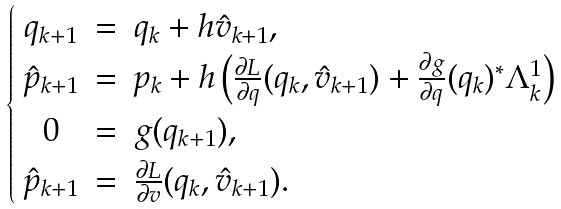Convert formula to latex. <formula><loc_0><loc_0><loc_500><loc_500>\begin{cases} \begin{array} { c c l } q _ { k + 1 } & = & q _ { k } + h \hat { v } _ { k + 1 } \text {,} \\ \hat { p } _ { k + 1 } & = & p _ { k } + h \left ( \frac { \partial L } { \partial q } ( q _ { k } , \hat { v } _ { k + 1 } ) + \frac { \partial g } { \partial q } ( q _ { k } ) ^ { * } \Lambda ^ { 1 } _ { k } \right ) \\ 0 & = & g ( q _ { k + 1 } ) \text {,} \\ \hat { p } _ { k + 1 } & = & \frac { \partial L } { \partial v } ( q _ { k } , \hat { v } _ { k + 1 } ) \text {.} \end{array} \end{cases}</formula> 